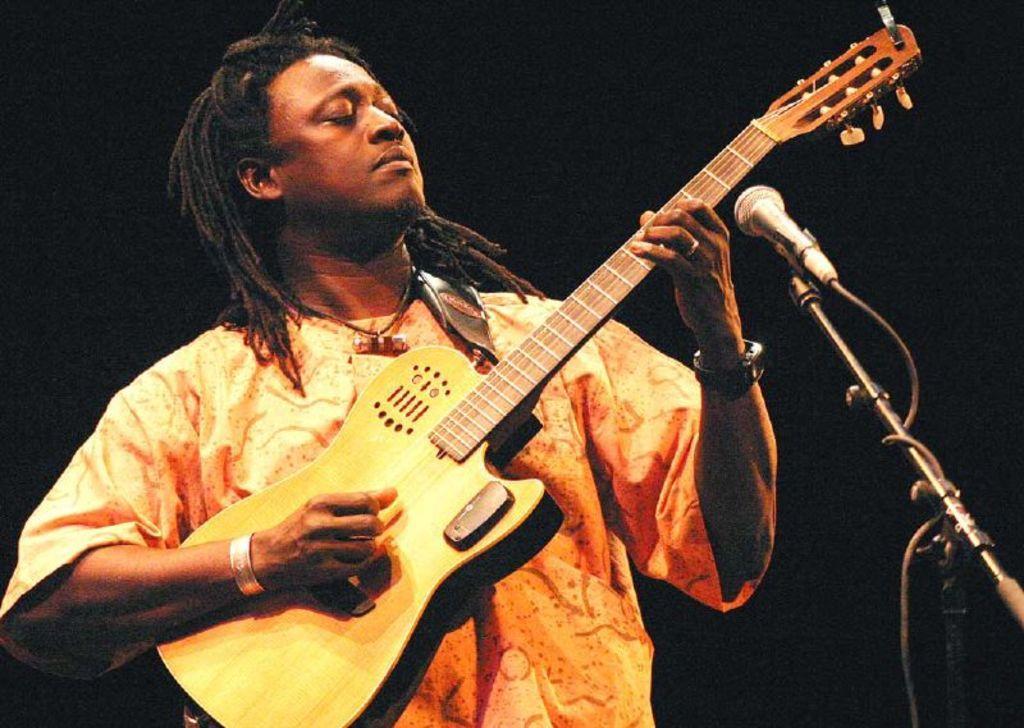Could you give a brief overview of what you see in this image? In a picture there is a person playing guitar in front of a microphone. 